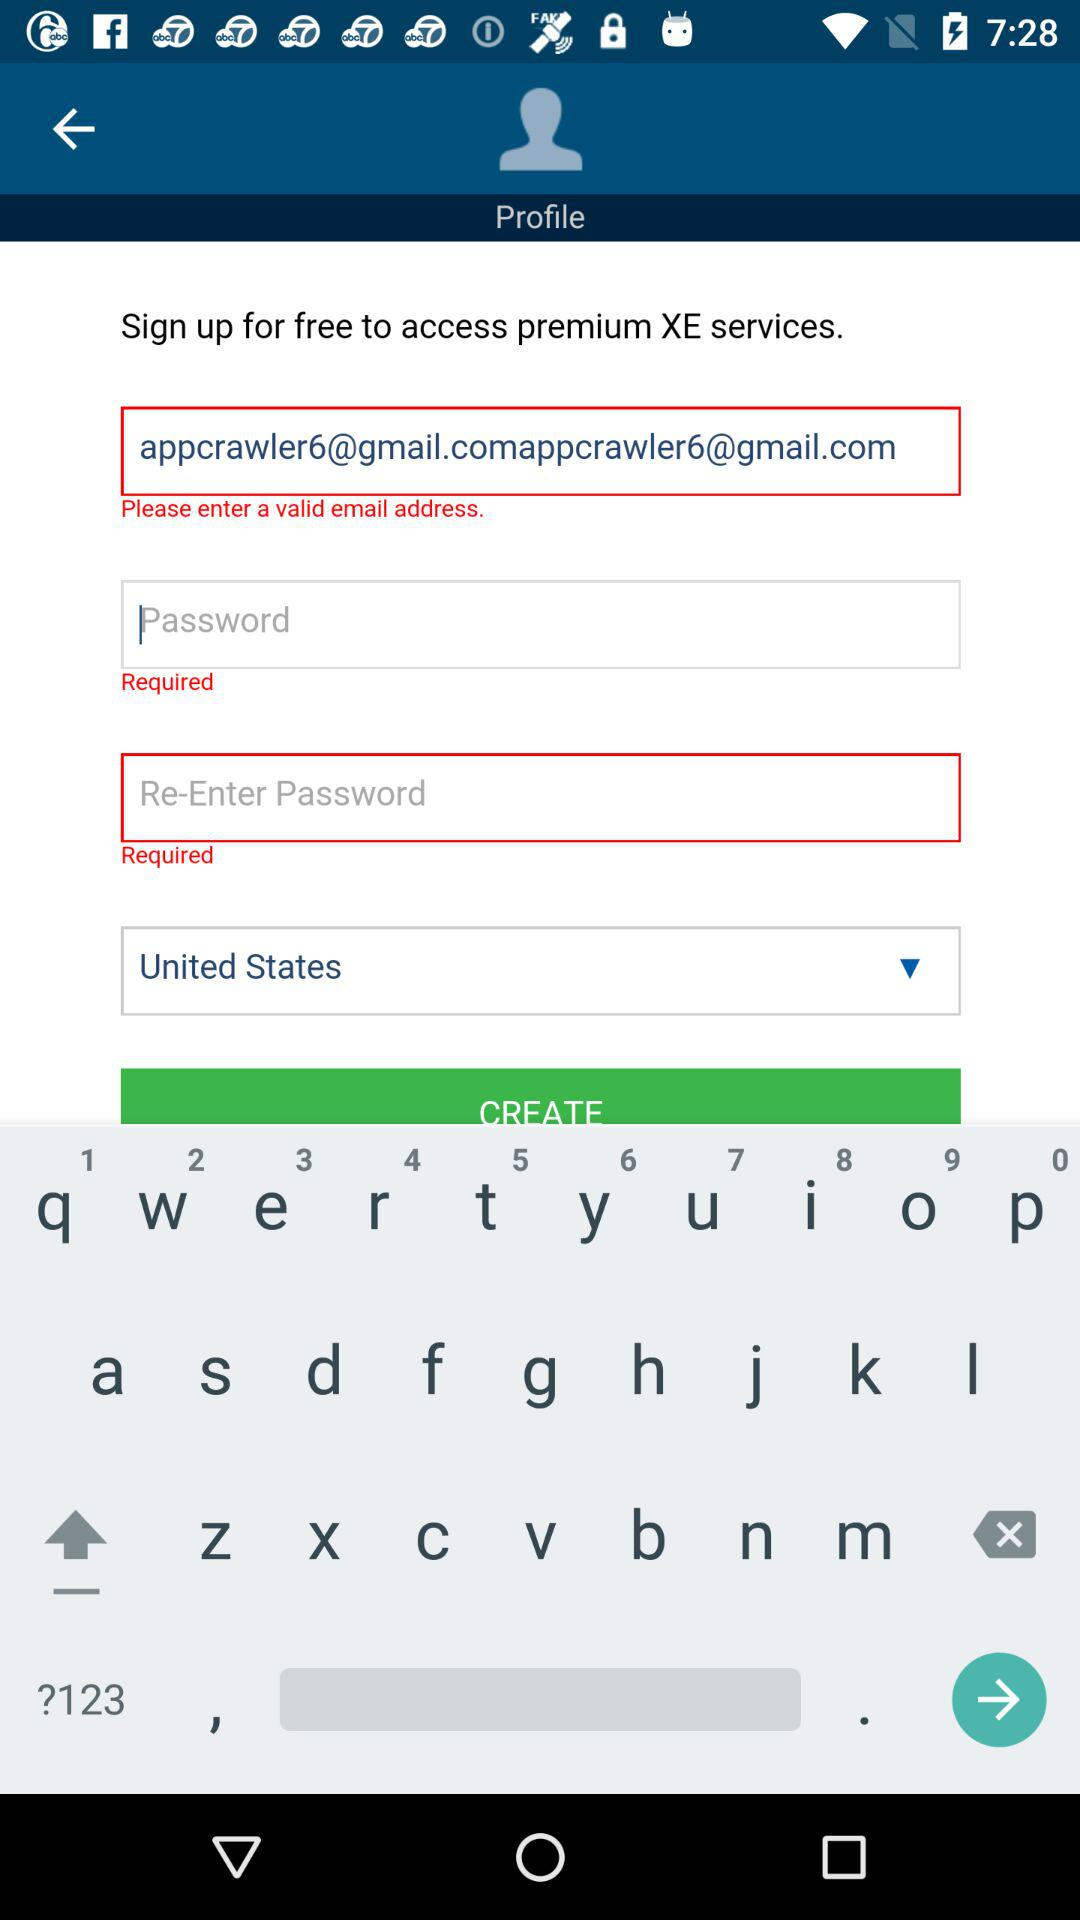What is the selected country? The selected country is the United States. 